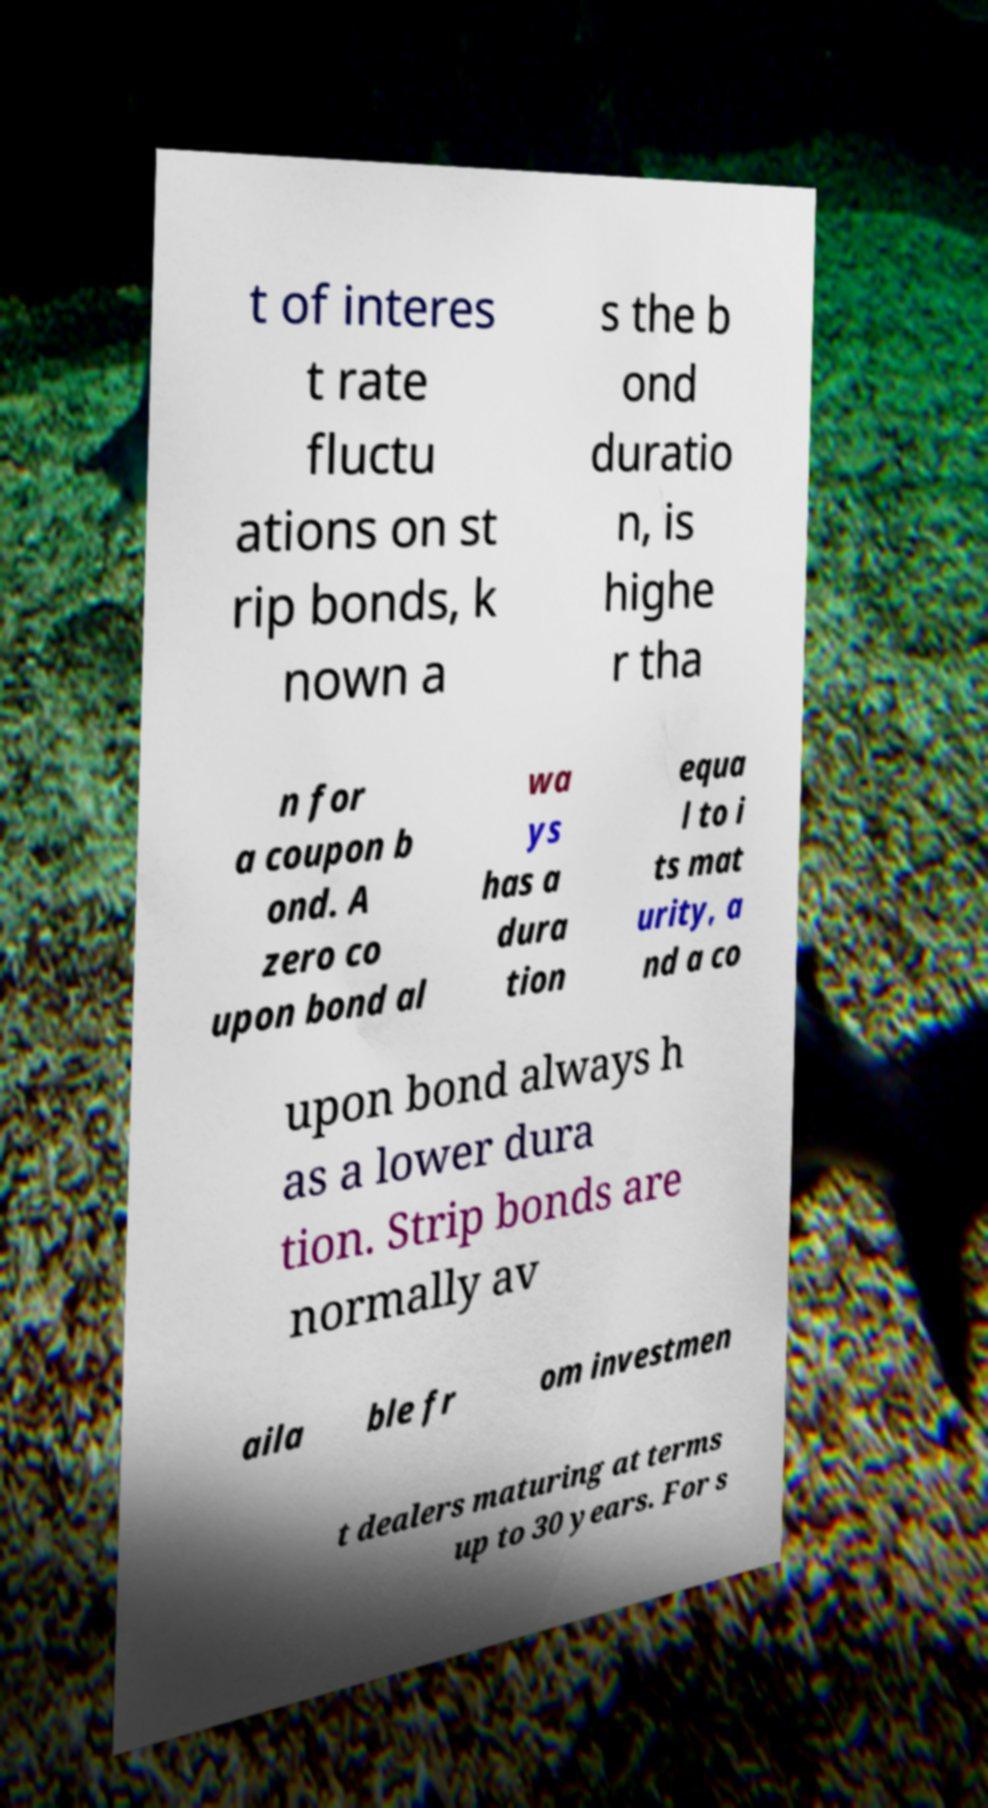Could you extract and type out the text from this image? t of interes t rate fluctu ations on st rip bonds, k nown a s the b ond duratio n, is highe r tha n for a coupon b ond. A zero co upon bond al wa ys has a dura tion equa l to i ts mat urity, a nd a co upon bond always h as a lower dura tion. Strip bonds are normally av aila ble fr om investmen t dealers maturing at terms up to 30 years. For s 